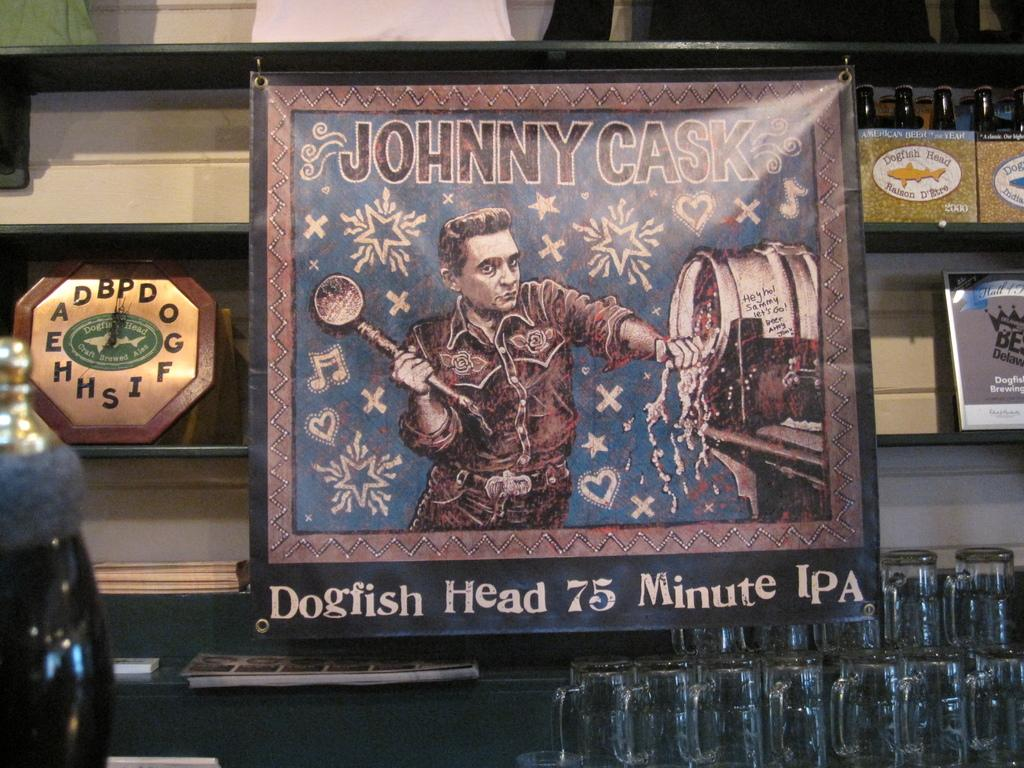What is inside the frame in the image? There is a poster with a person present in the frame. What else can be seen on the poster besides the person? There is some text on the poster. What object is visible in the image that can be used to tell time? There is a clock in the image. What type of items can be seen on a shelf in the image? There are many bottles on a shelf in the image. Can you describe the goose that is sitting on the shelf with the bottles in the image? There is no goose present on the shelf with the bottles in the image. 